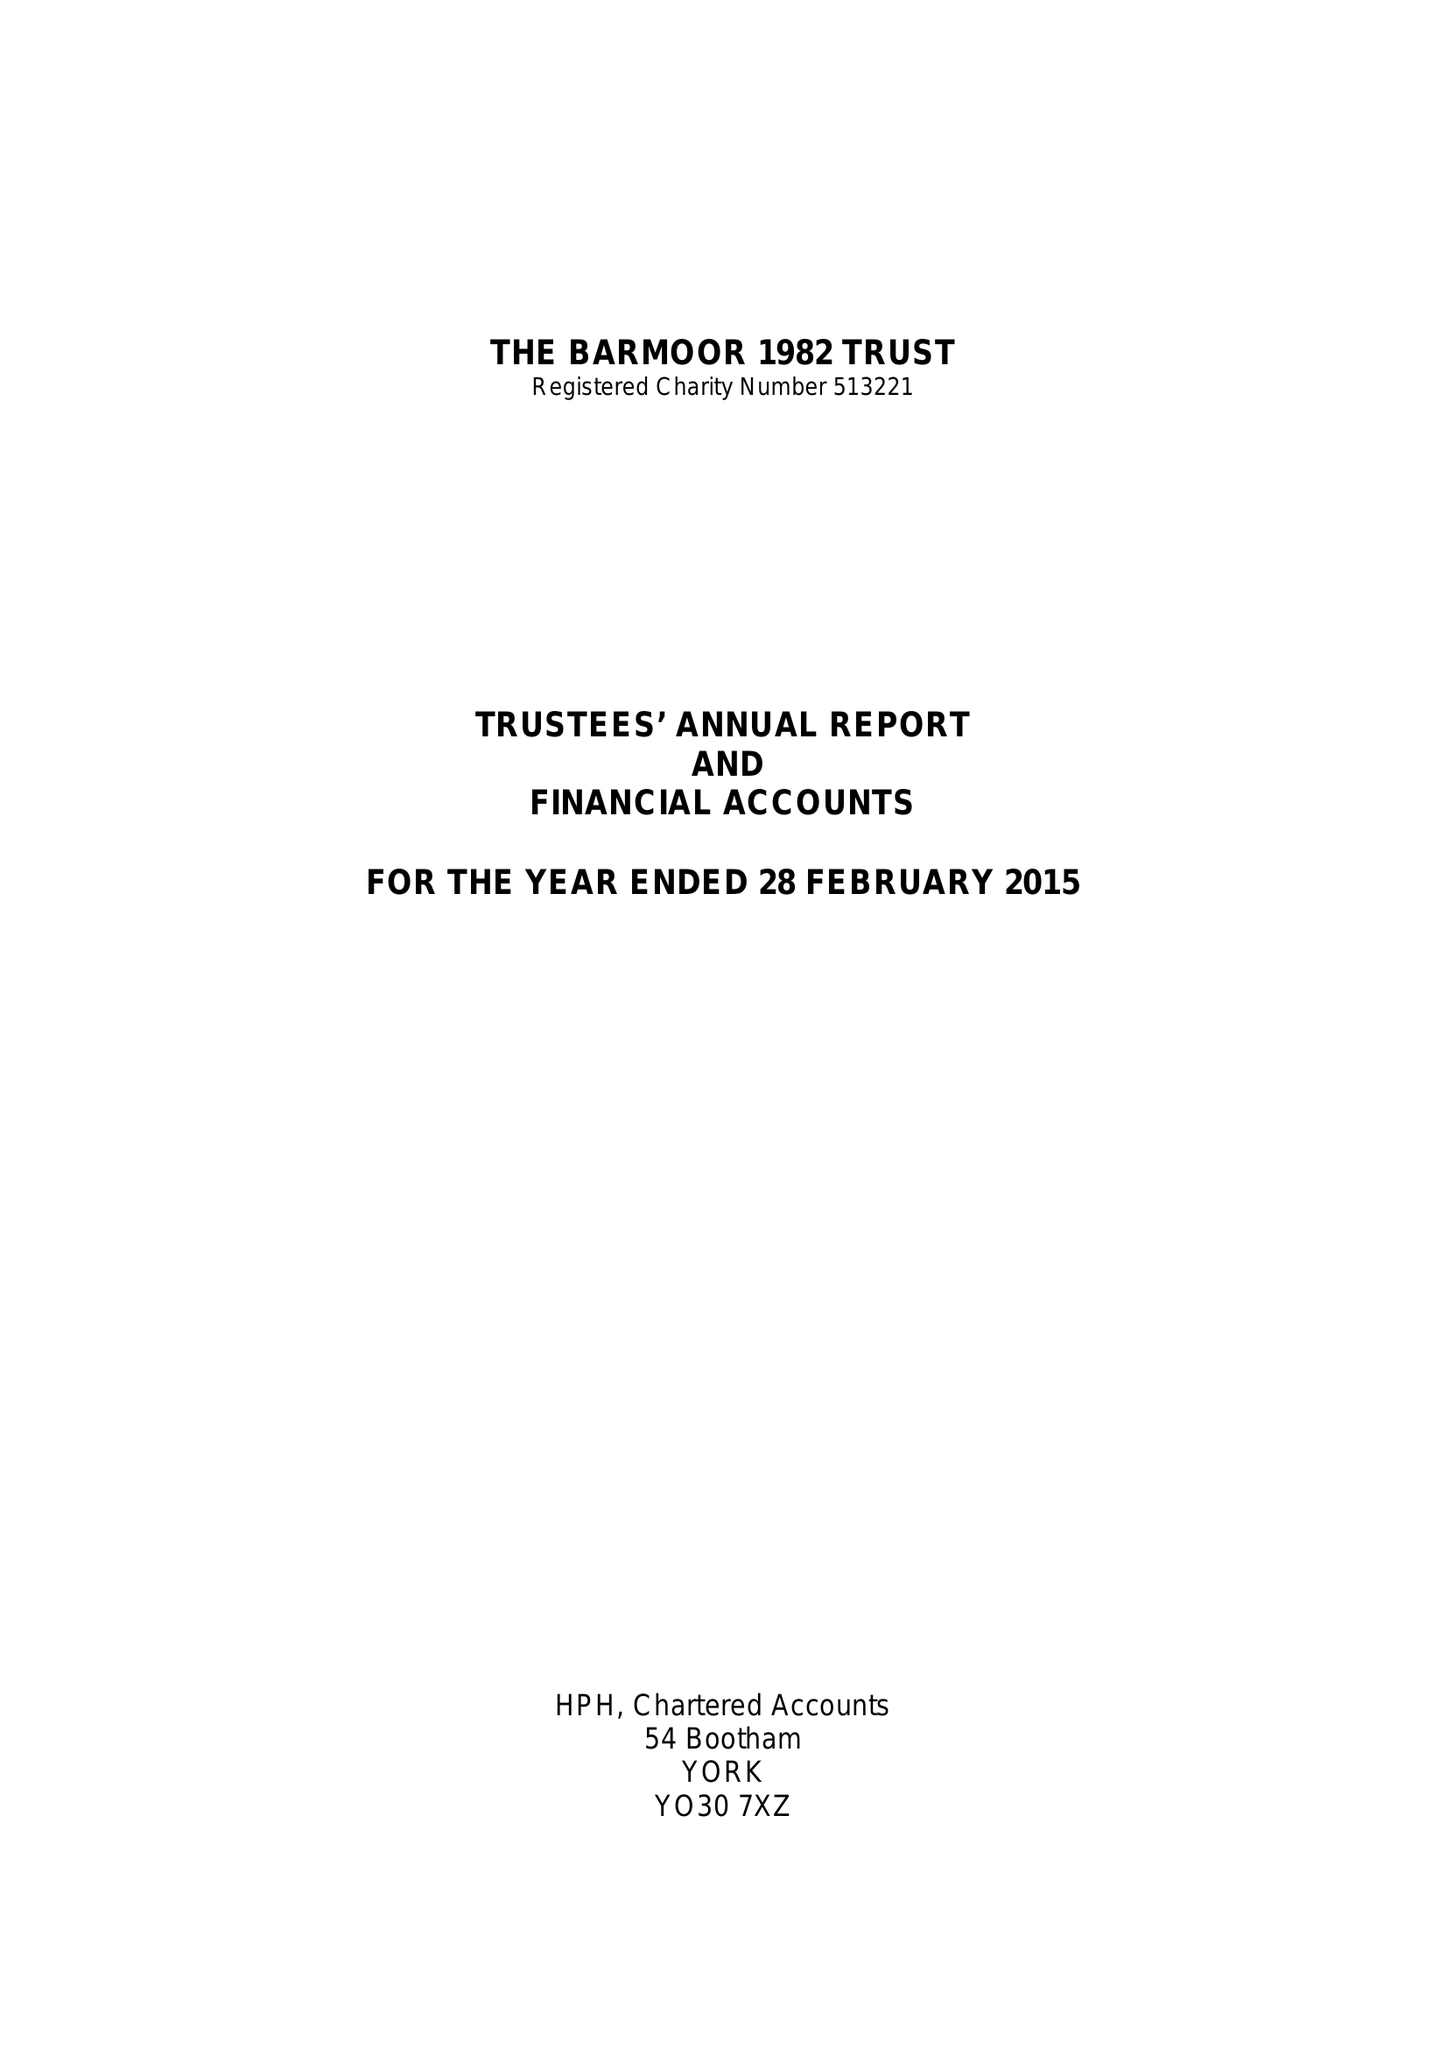What is the value for the address__post_town?
Answer the question using a single word or phrase. LONDON 